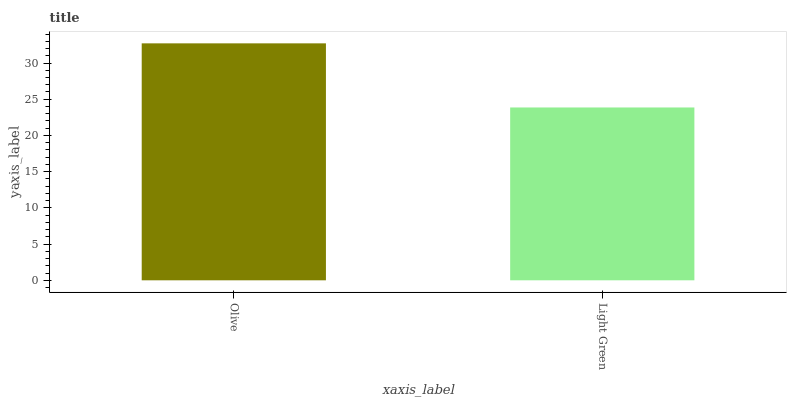Is Light Green the minimum?
Answer yes or no. Yes. Is Olive the maximum?
Answer yes or no. Yes. Is Light Green the maximum?
Answer yes or no. No. Is Olive greater than Light Green?
Answer yes or no. Yes. Is Light Green less than Olive?
Answer yes or no. Yes. Is Light Green greater than Olive?
Answer yes or no. No. Is Olive less than Light Green?
Answer yes or no. No. Is Olive the high median?
Answer yes or no. Yes. Is Light Green the low median?
Answer yes or no. Yes. Is Light Green the high median?
Answer yes or no. No. Is Olive the low median?
Answer yes or no. No. 